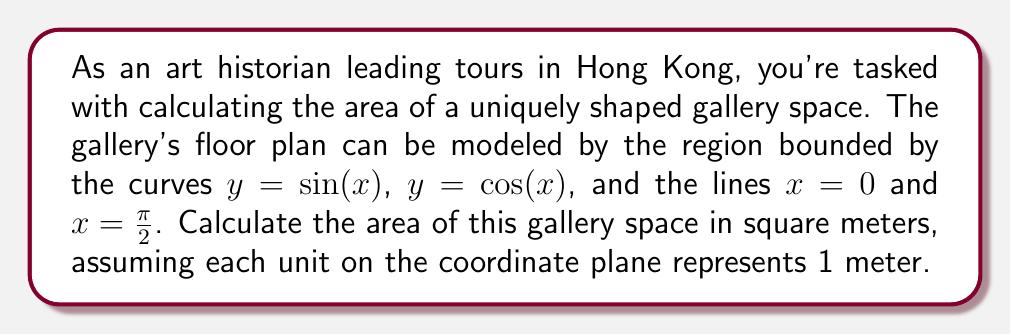Provide a solution to this math problem. To calculate the area of this irregularly shaped gallery space, we need to use integration techniques. Let's approach this step-by-step:

1) The region is bounded by four curves/lines:
   - $y = \sin(x)$ (upper bound)
   - $y = \cos(x)$ (lower bound)
   - $x = 0$ (left bound)
   - $x = \frac{\pi}{2}$ (right bound)

2) The area can be calculated by integrating the difference between the upper and lower bounds:

   $$A = \int_0^{\frac{\pi}{2}} [\sin(x) - \cos(x)] dx$$

3) To solve this integral, we can use the substitution method or recall the antiderivatives:

   $$\int \sin(x) dx = -\cos(x) + C$$
   $$\int \cos(x) dx = \sin(x) + C$$

4) Applying these:

   $$A = [-\cos(x) - \sin(x)]_0^{\frac{\pi}{2}}$$

5) Evaluating the integral:

   $$A = [-\cos(\frac{\pi}{2}) - \sin(\frac{\pi}{2})] - [-\cos(0) - \sin(0)]$$

6) Simplify:

   $$A = [0 - 1] - [-1 - 0] = -1 - (-1) = 2$$

7) Therefore, the area of the gallery space is 2 square meters.
Answer: 2 square meters 